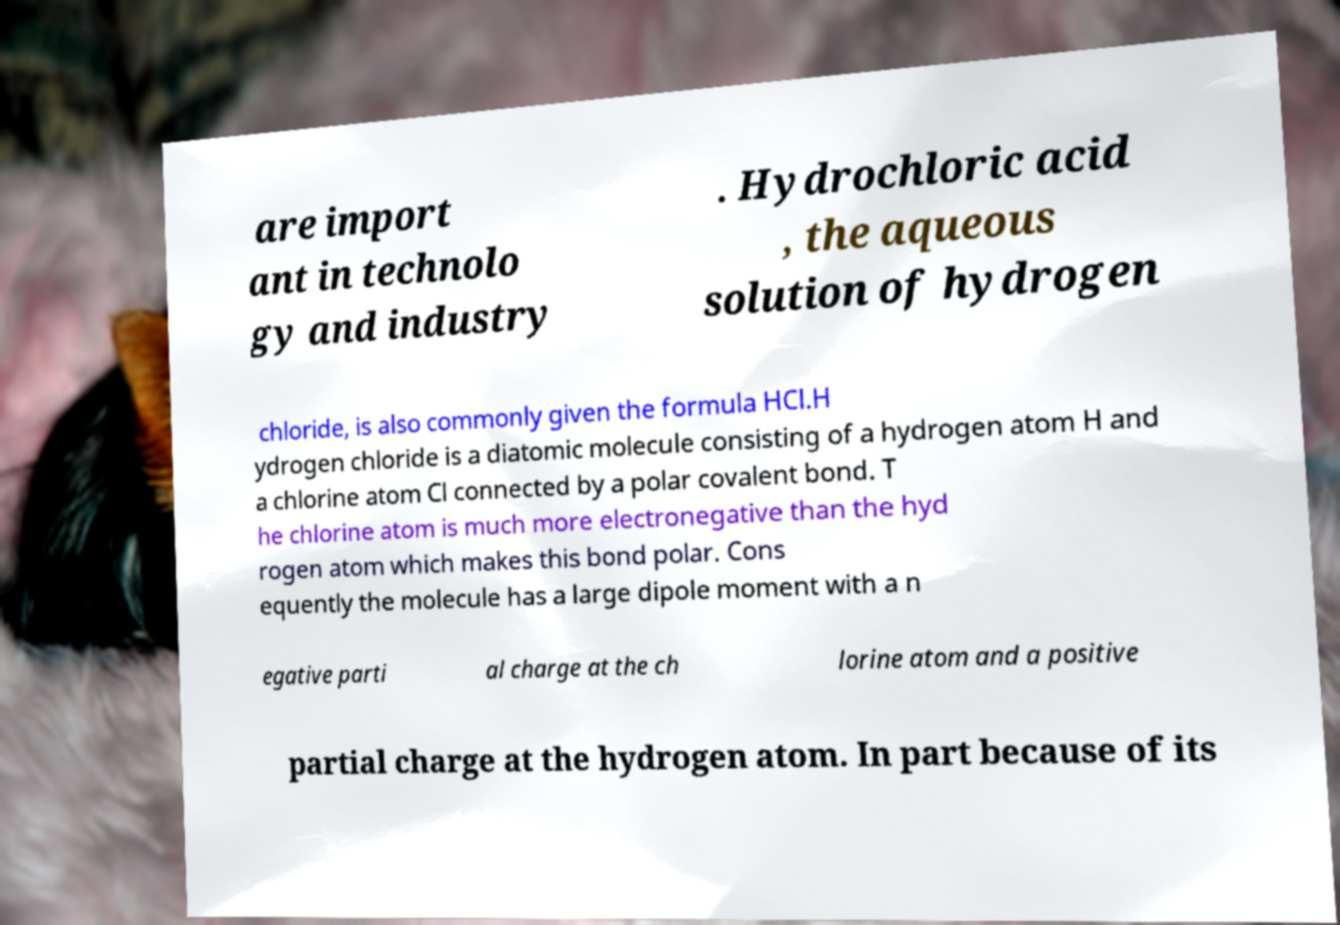For documentation purposes, I need the text within this image transcribed. Could you provide that? are import ant in technolo gy and industry . Hydrochloric acid , the aqueous solution of hydrogen chloride, is also commonly given the formula HCl.H ydrogen chloride is a diatomic molecule consisting of a hydrogen atom H and a chlorine atom Cl connected by a polar covalent bond. T he chlorine atom is much more electronegative than the hyd rogen atom which makes this bond polar. Cons equently the molecule has a large dipole moment with a n egative parti al charge at the ch lorine atom and a positive partial charge at the hydrogen atom. In part because of its 